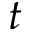Convert formula to latex. <formula><loc_0><loc_0><loc_500><loc_500>t</formula> 